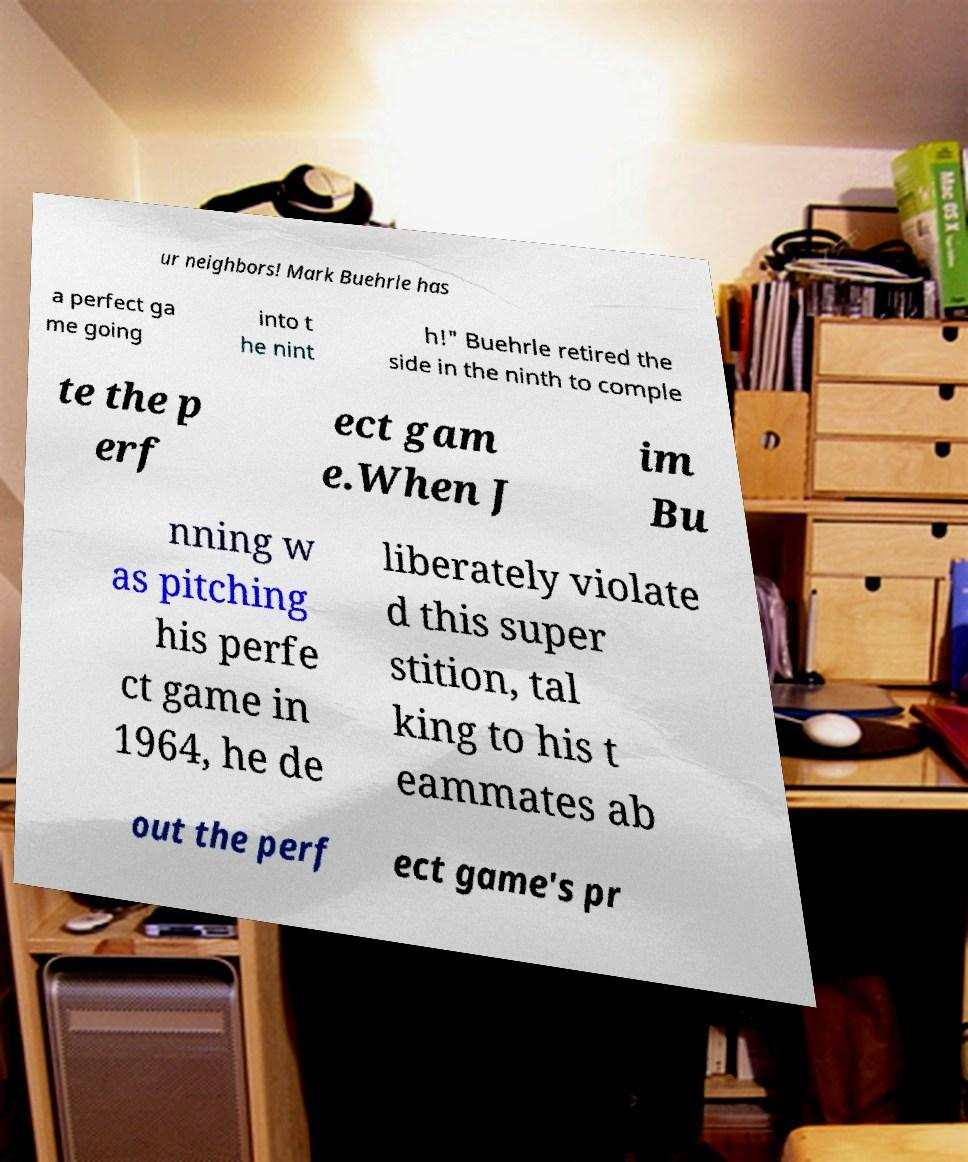I need the written content from this picture converted into text. Can you do that? ur neighbors! Mark Buehrle has a perfect ga me going into t he nint h!" Buehrle retired the side in the ninth to comple te the p erf ect gam e.When J im Bu nning w as pitching his perfe ct game in 1964, he de liberately violate d this super stition, tal king to his t eammates ab out the perf ect game's pr 